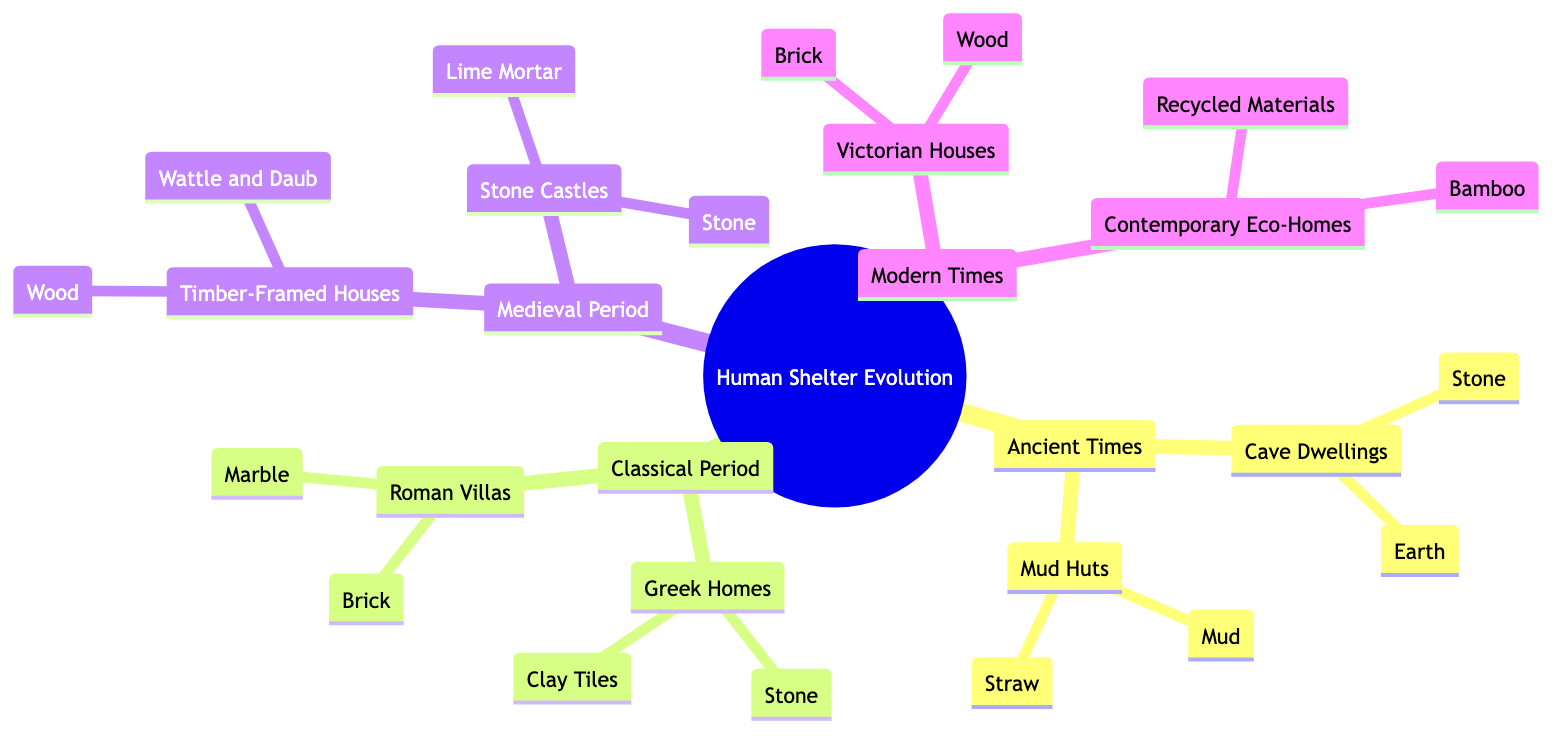What types of materials were used in cave dwellings? The diagram lists "Stone" and "Earth" as the materials used for cave dwellings under the "Ancient Times" category.
Answer: Stone, Earth Which period does the construction of Roman villas fall under? The diagram classifies Roman villas under the "Classical Period," as stated in the section that describes their materials and construction techniques.
Answer: Classical Period How many main periods are represented in the diagram? By counting the sections in the diagram, which include "Ancient Times," "Classical Period," "Medieval Period," and "Modern Times," we find there are four main periods.
Answer: Four What are the two materials used in Victorian houses? The relevant section of the diagram specifies "Brick" and "Wood" as the materials used in the construction of Victorian houses.
Answer: Brick, Wood Which type of house is made from recycled materials? The diagram indicates that "Contemporary Eco-Homes" are constructed using "Recycled Materials," highlighting a modern emphasis on sustainability.
Answer: Contemporary Eco-Homes What is the main building material for stone castles? According to the diagram, "Stone" is listed as the primary material for constructing stone castles during the Medieval Period.
Answer: Stone How do the materials used in Greek homes contrast with those in mud huts? Greek homes utilize "Stone" and "Clay Tiles," while mud huts are made of "Mud" and "Straw"; this illustrates the difference in material sophistication between classical and ancient structures.
Answer: Stone, Clay Tiles vs. Mud, Straw Which shelter type is associated with the use of bamboo? The diagram specifies "Contemporary Eco-Homes" as the type of shelter associated with the use of "Bamboo" as one of their materials, showing a modern shift towards eco-friendly building materials.
Answer: Contemporary Eco-Homes 